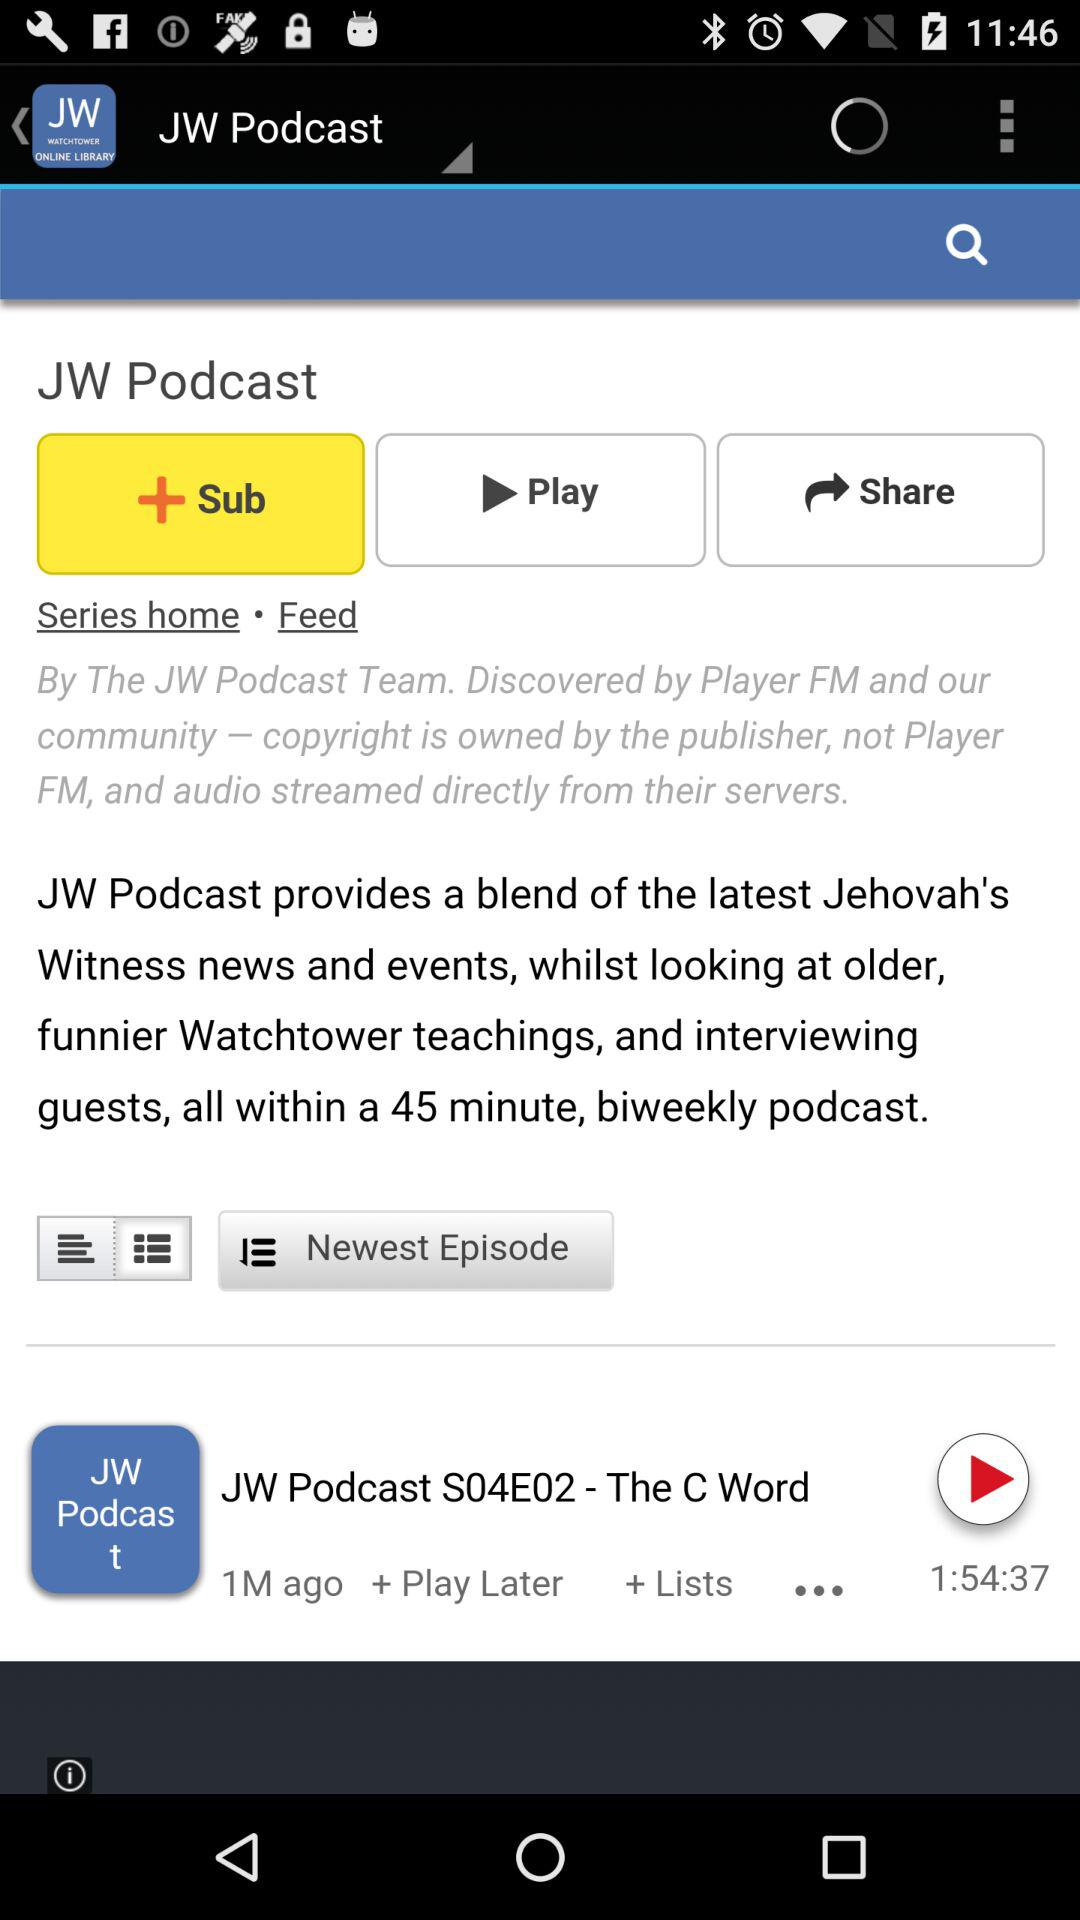Which option is selected? The selected option is "Sub". 